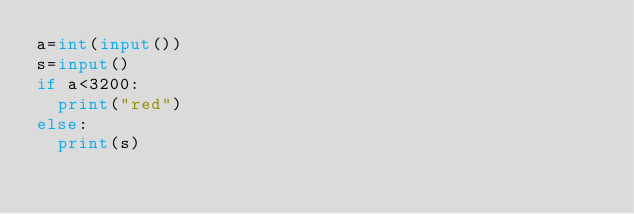<code> <loc_0><loc_0><loc_500><loc_500><_Python_>a=int(input())
s=input()
if a<3200:
  print("red")
else:
  print(s)</code> 